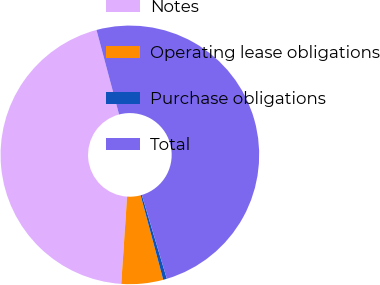Convert chart. <chart><loc_0><loc_0><loc_500><loc_500><pie_chart><fcel>Notes<fcel>Operating lease obligations<fcel>Purchase obligations<fcel>Total<nl><fcel>44.78%<fcel>5.22%<fcel>0.46%<fcel>49.54%<nl></chart> 